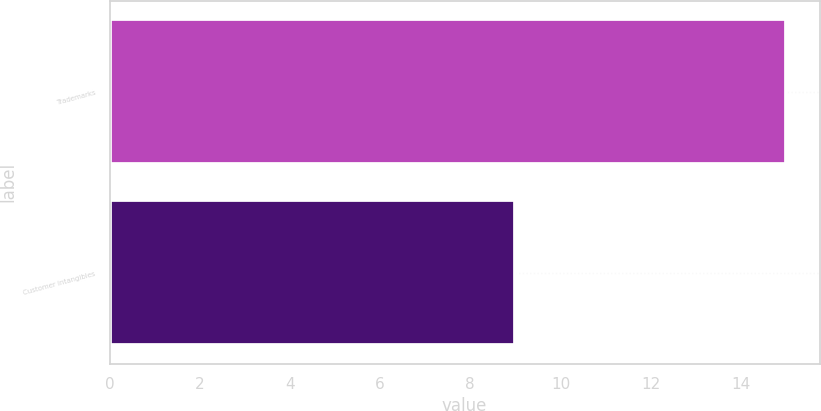Convert chart to OTSL. <chart><loc_0><loc_0><loc_500><loc_500><bar_chart><fcel>Trademarks<fcel>Customer intangibles<nl><fcel>15<fcel>9<nl></chart> 